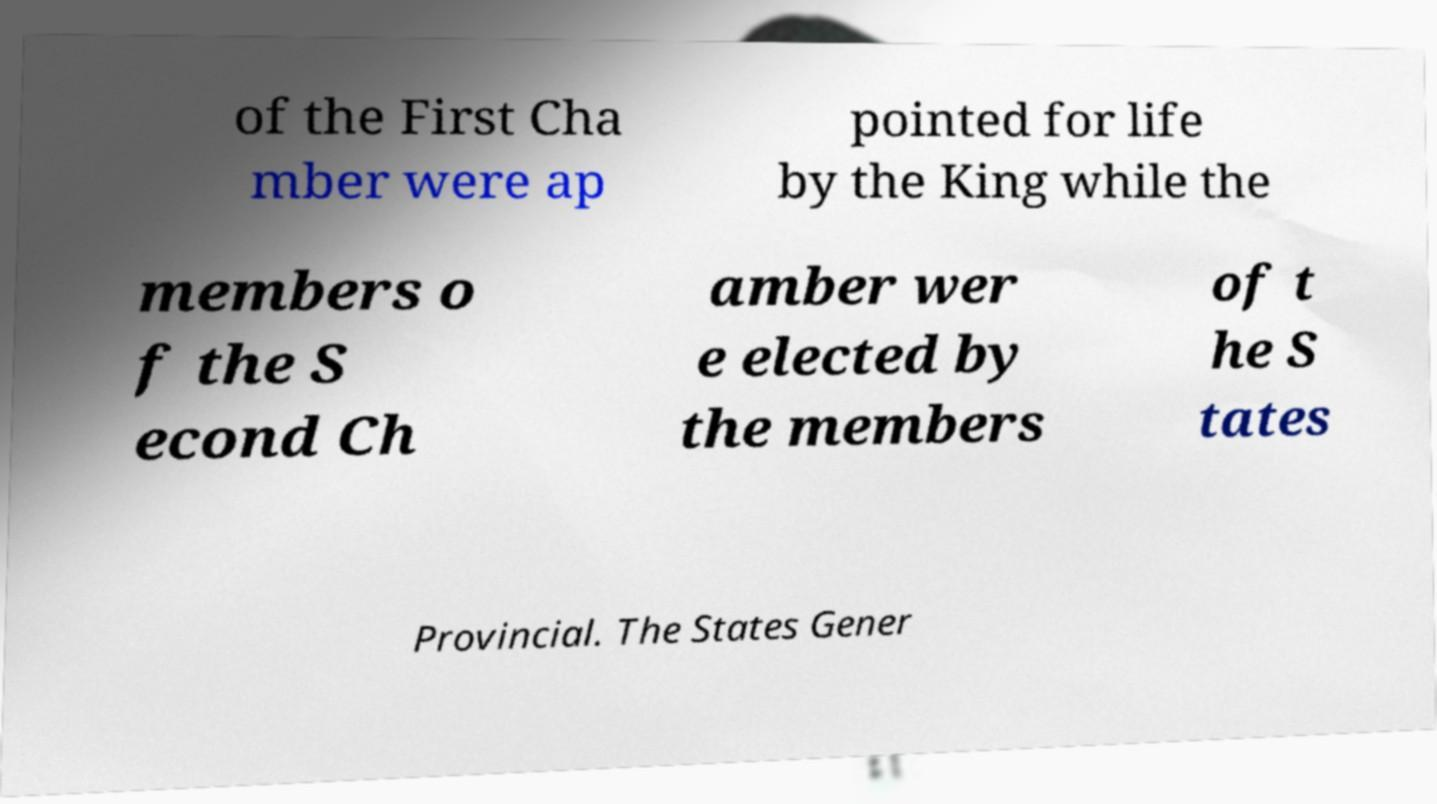Could you assist in decoding the text presented in this image and type it out clearly? of the First Cha mber were ap pointed for life by the King while the members o f the S econd Ch amber wer e elected by the members of t he S tates Provincial. The States Gener 